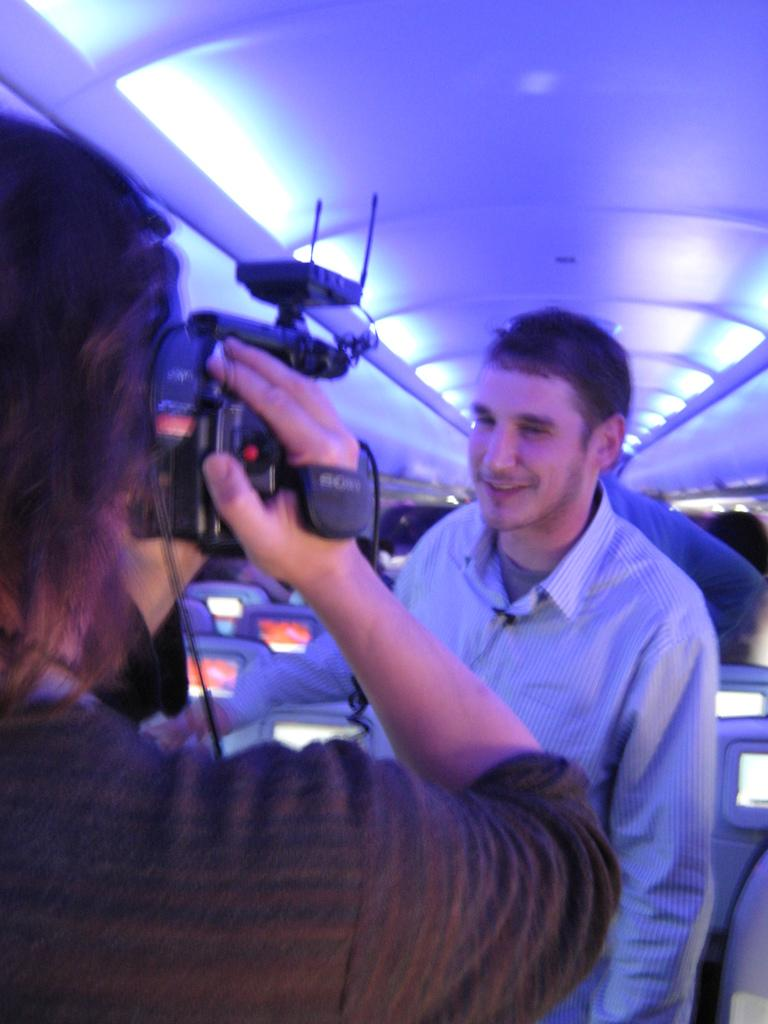What is the main subject in the center of the image? There is a man standing in the center of the image. Who else is present in the image? There is a person standing on the left side of the image, holding a camera. What can be seen in the background of the image? There are screens and a roof present in the background of the image. How does the man in the center of the image express his anger? The image does not show any indication of the man expressing anger, as there is no mention of his emotions or actions related to anger in the provided facts. 